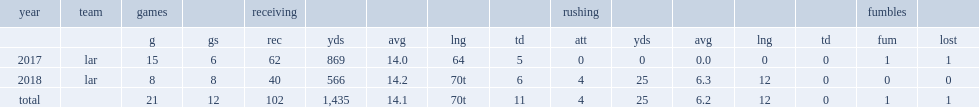When did kupp finish his rookie season? 2017.0. 